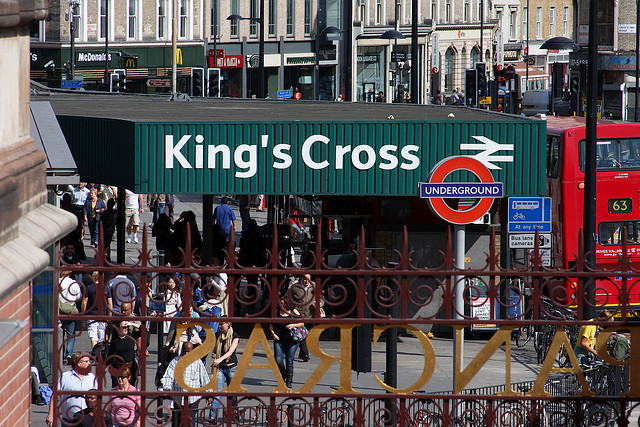Please transcribe the text in this image. King's Cross UNDERGROUND ANCRAS 63 E M McDonald's S 